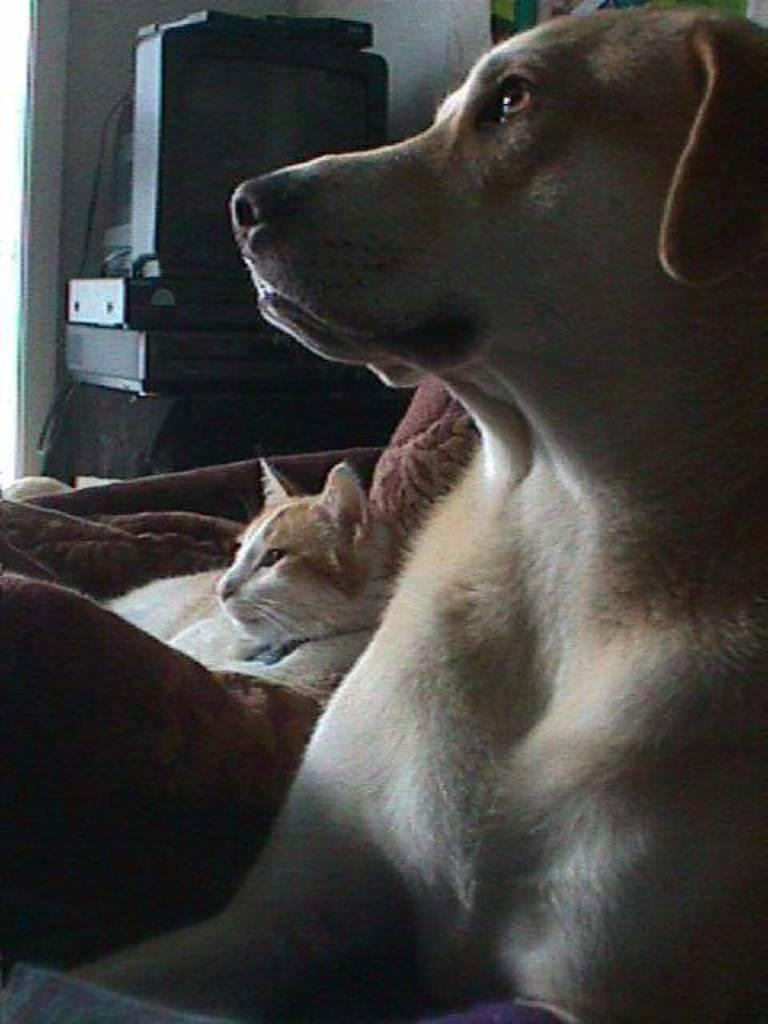What animals are in the foreground of the image? There is a dog and a cat in the foreground of the image. What are the dog and cat doing in the image? Both the dog and cat are on a surface in the image. What can be seen in the background of the image? There is a television and devices placed on a table in the background of the image. What type of silver material is being used by the dog to write with a quill in the image? There is no silver material or quill present in the image; the dog and cat are simply on a surface. 